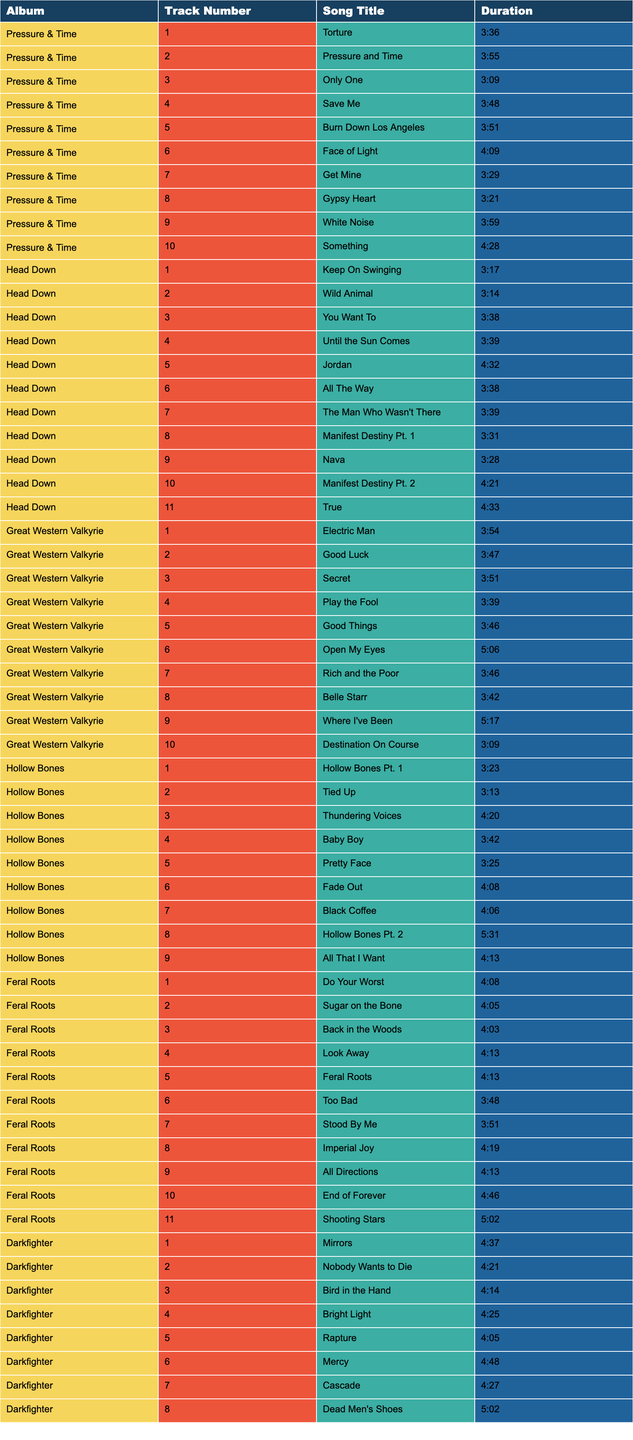What is the duration of the song "Only One"? The table lists the song "Only One" from the album "Pressure & Time" along with its duration, which is 3:09.
Answer: 3:09 How many tracks are on the album "Hollow Bones"? The table shows the album "Hollow Bones" has 9 tracks listed.
Answer: 9 Which album has the longest track? By checking the durations, "Hollow Bones Pt. 2" from the album "Hollow Bones" is the longest track with a duration of 5:31.
Answer: Hollow Bones What is the average duration of the songs in "Feral Roots"? The total duration of the songs in "Feral Roots" can be calculated as 4:08 + 4:05 + 4:03 + 4:13 + 4:13 + 3:48 + 3:51 + 4:19 + 4:13 + 4:46 + 5:02 = 47:04. There are 11 tracks, so the average duration is 47:04 / 11 ≈ 4:16.
Answer: 4:16 Which track from "Darkfighter" has the shortest duration? The table indicates that "Rapture" has the shortest duration among the "Darkfighter" tracks at 4:05.
Answer: Rapture Is there a song titled "Electric Man" in the table? Yes, the table shows that "Electric Man" is a track from the album "Great Western Valkyrie".
Answer: Yes What is the total duration of all tracks in "Pressure & Time"? From the song durations listed in "Pressure & Time", we add them up: 3:36 + 3:55 + 3:09 + 3:48 + 3:51 + 4:09 + 3:29 + 3:21 + 3:59 + 4:28 = 37:06.
Answer: 37:06 Which album features the track "Keep On Swinging"? The table shows that "Keep On Swinging" is from the album "Head Down".
Answer: Head Down How many songs in total are on all the albums listed? By counting all the tracks listed in the table for each album and summing them up: 10 (Pressure & Time) + 11 (Head Down) + 10 (Great Western Valkyrie) + 9 (Hollow Bones) + 11 (Feral Roots) + 8 (Darkfighter) = 69 tracks in total.
Answer: 69 Which album has the shortest average track duration? After calculating the average track durations for each album, "Hollow Bones" has the shortest average duration of about 4:02.
Answer: Hollow Bones 